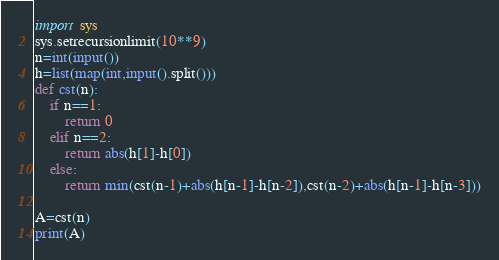Convert code to text. <code><loc_0><loc_0><loc_500><loc_500><_Python_>import sys
sys.setrecursionlimit(10**9)
n=int(input())
h=list(map(int,input().split()))
def cst(n):
    if n==1:
        return 0
    elif n==2:
        return abs(h[1]-h[0])   
    else:
        return min(cst(n-1)+abs(h[n-1]-h[n-2]),cst(n-2)+abs(h[n-1]-h[n-3]))

A=cst(n)
print(A)</code> 